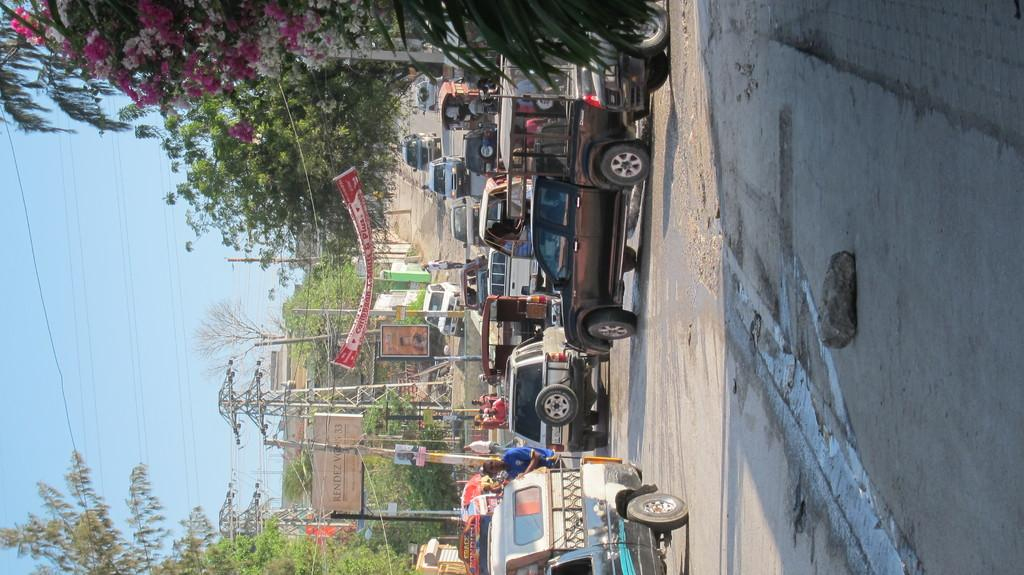What types of objects are present in the image? There are vehicles and people in the image. What can be seen in the background of the image? There are buildings, trees, poles, a banner, and posters in the background of the image. What part of the natural environment is visible in the image? The sky is visible in the background of the image. How many sacks are being carried by the people in the image? There are no sacks visible in the image; the people are not carrying any sacks. What type of voyage is depicted in the image? There is no voyage depicted in the image; it features vehicles, people, and background elements. 